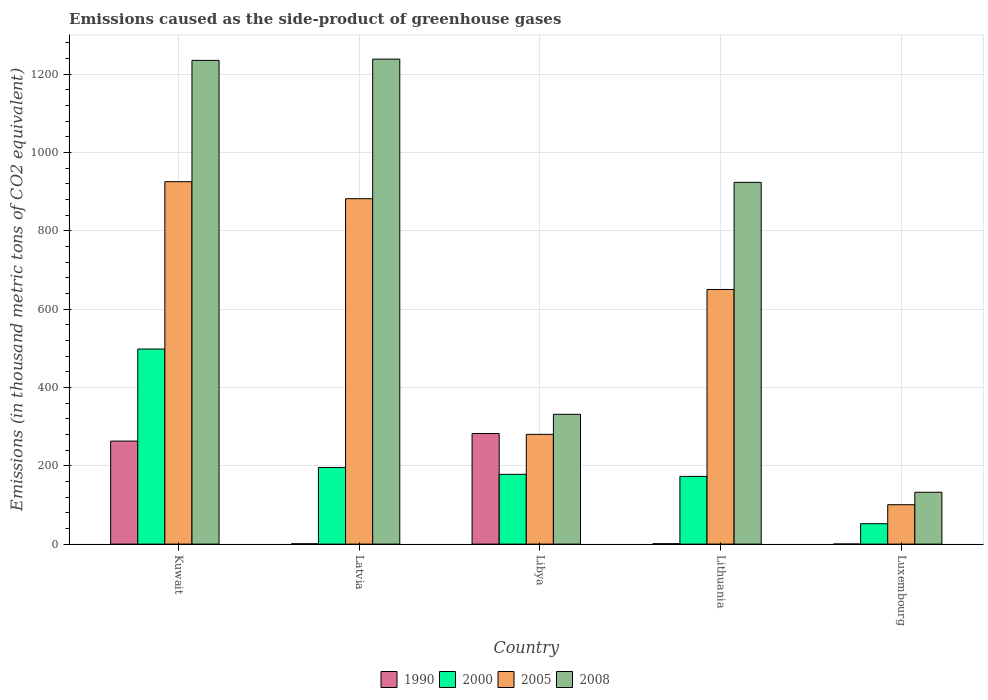How many different coloured bars are there?
Offer a very short reply. 4. How many groups of bars are there?
Your answer should be compact. 5. Are the number of bars per tick equal to the number of legend labels?
Your response must be concise. Yes. How many bars are there on the 3rd tick from the left?
Provide a succinct answer. 4. How many bars are there on the 5th tick from the right?
Your answer should be compact. 4. What is the label of the 4th group of bars from the left?
Keep it short and to the point. Lithuania. In how many cases, is the number of bars for a given country not equal to the number of legend labels?
Provide a succinct answer. 0. What is the emissions caused as the side-product of greenhouse gases in 2005 in Lithuania?
Offer a very short reply. 650.3. Across all countries, what is the maximum emissions caused as the side-product of greenhouse gases in 2005?
Your answer should be compact. 925.6. Across all countries, what is the minimum emissions caused as the side-product of greenhouse gases in 2000?
Your answer should be very brief. 52.1. In which country was the emissions caused as the side-product of greenhouse gases in 2005 maximum?
Offer a very short reply. Kuwait. In which country was the emissions caused as the side-product of greenhouse gases in 1990 minimum?
Keep it short and to the point. Luxembourg. What is the total emissions caused as the side-product of greenhouse gases in 1990 in the graph?
Your answer should be compact. 547.5. What is the difference between the emissions caused as the side-product of greenhouse gases in 2005 in Kuwait and that in Libya?
Provide a succinct answer. 645.3. What is the difference between the emissions caused as the side-product of greenhouse gases in 1990 in Kuwait and the emissions caused as the side-product of greenhouse gases in 2005 in Latvia?
Offer a very short reply. -619. What is the average emissions caused as the side-product of greenhouse gases in 1990 per country?
Keep it short and to the point. 109.5. What is the difference between the emissions caused as the side-product of greenhouse gases of/in 2000 and emissions caused as the side-product of greenhouse gases of/in 2005 in Luxembourg?
Make the answer very short. -48.5. In how many countries, is the emissions caused as the side-product of greenhouse gases in 2000 greater than 800 thousand metric tons?
Keep it short and to the point. 0. What is the ratio of the emissions caused as the side-product of greenhouse gases in 2005 in Kuwait to that in Lithuania?
Ensure brevity in your answer.  1.42. Is the difference between the emissions caused as the side-product of greenhouse gases in 2000 in Lithuania and Luxembourg greater than the difference between the emissions caused as the side-product of greenhouse gases in 2005 in Lithuania and Luxembourg?
Ensure brevity in your answer.  No. What is the difference between the highest and the second highest emissions caused as the side-product of greenhouse gases in 1990?
Offer a terse response. -281.4. What is the difference between the highest and the lowest emissions caused as the side-product of greenhouse gases in 1990?
Offer a terse response. 282.2. In how many countries, is the emissions caused as the side-product of greenhouse gases in 2008 greater than the average emissions caused as the side-product of greenhouse gases in 2008 taken over all countries?
Keep it short and to the point. 3. What does the 4th bar from the left in Kuwait represents?
Make the answer very short. 2008. Is it the case that in every country, the sum of the emissions caused as the side-product of greenhouse gases in 2005 and emissions caused as the side-product of greenhouse gases in 2000 is greater than the emissions caused as the side-product of greenhouse gases in 2008?
Make the answer very short. No. Are the values on the major ticks of Y-axis written in scientific E-notation?
Ensure brevity in your answer.  No. Does the graph contain grids?
Your response must be concise. Yes. How many legend labels are there?
Offer a terse response. 4. What is the title of the graph?
Your response must be concise. Emissions caused as the side-product of greenhouse gases. What is the label or title of the X-axis?
Keep it short and to the point. Country. What is the label or title of the Y-axis?
Provide a succinct answer. Emissions (in thousand metric tons of CO2 equivalent). What is the Emissions (in thousand metric tons of CO2 equivalent) of 1990 in Kuwait?
Your response must be concise. 263.1. What is the Emissions (in thousand metric tons of CO2 equivalent) of 2000 in Kuwait?
Give a very brief answer. 498.2. What is the Emissions (in thousand metric tons of CO2 equivalent) of 2005 in Kuwait?
Provide a succinct answer. 925.6. What is the Emissions (in thousand metric tons of CO2 equivalent) of 2008 in Kuwait?
Offer a terse response. 1235.4. What is the Emissions (in thousand metric tons of CO2 equivalent) in 2000 in Latvia?
Provide a succinct answer. 195.7. What is the Emissions (in thousand metric tons of CO2 equivalent) of 2005 in Latvia?
Your answer should be compact. 882.1. What is the Emissions (in thousand metric tons of CO2 equivalent) in 2008 in Latvia?
Your answer should be very brief. 1238.6. What is the Emissions (in thousand metric tons of CO2 equivalent) in 1990 in Libya?
Offer a very short reply. 282.4. What is the Emissions (in thousand metric tons of CO2 equivalent) in 2000 in Libya?
Your response must be concise. 178.2. What is the Emissions (in thousand metric tons of CO2 equivalent) of 2005 in Libya?
Ensure brevity in your answer.  280.3. What is the Emissions (in thousand metric tons of CO2 equivalent) of 2008 in Libya?
Your answer should be compact. 331.5. What is the Emissions (in thousand metric tons of CO2 equivalent) in 2000 in Lithuania?
Your response must be concise. 172.9. What is the Emissions (in thousand metric tons of CO2 equivalent) of 2005 in Lithuania?
Provide a short and direct response. 650.3. What is the Emissions (in thousand metric tons of CO2 equivalent) of 2008 in Lithuania?
Offer a terse response. 923.9. What is the Emissions (in thousand metric tons of CO2 equivalent) of 1990 in Luxembourg?
Provide a succinct answer. 0.2. What is the Emissions (in thousand metric tons of CO2 equivalent) in 2000 in Luxembourg?
Keep it short and to the point. 52.1. What is the Emissions (in thousand metric tons of CO2 equivalent) of 2005 in Luxembourg?
Keep it short and to the point. 100.6. What is the Emissions (in thousand metric tons of CO2 equivalent) of 2008 in Luxembourg?
Offer a very short reply. 132.4. Across all countries, what is the maximum Emissions (in thousand metric tons of CO2 equivalent) of 1990?
Provide a succinct answer. 282.4. Across all countries, what is the maximum Emissions (in thousand metric tons of CO2 equivalent) in 2000?
Provide a succinct answer. 498.2. Across all countries, what is the maximum Emissions (in thousand metric tons of CO2 equivalent) of 2005?
Provide a short and direct response. 925.6. Across all countries, what is the maximum Emissions (in thousand metric tons of CO2 equivalent) in 2008?
Offer a very short reply. 1238.6. Across all countries, what is the minimum Emissions (in thousand metric tons of CO2 equivalent) in 2000?
Ensure brevity in your answer.  52.1. Across all countries, what is the minimum Emissions (in thousand metric tons of CO2 equivalent) of 2005?
Keep it short and to the point. 100.6. Across all countries, what is the minimum Emissions (in thousand metric tons of CO2 equivalent) of 2008?
Provide a short and direct response. 132.4. What is the total Emissions (in thousand metric tons of CO2 equivalent) of 1990 in the graph?
Provide a short and direct response. 547.5. What is the total Emissions (in thousand metric tons of CO2 equivalent) of 2000 in the graph?
Ensure brevity in your answer.  1097.1. What is the total Emissions (in thousand metric tons of CO2 equivalent) of 2005 in the graph?
Provide a succinct answer. 2838.9. What is the total Emissions (in thousand metric tons of CO2 equivalent) in 2008 in the graph?
Your answer should be very brief. 3861.8. What is the difference between the Emissions (in thousand metric tons of CO2 equivalent) in 1990 in Kuwait and that in Latvia?
Provide a succinct answer. 262.3. What is the difference between the Emissions (in thousand metric tons of CO2 equivalent) in 2000 in Kuwait and that in Latvia?
Provide a short and direct response. 302.5. What is the difference between the Emissions (in thousand metric tons of CO2 equivalent) of 2005 in Kuwait and that in Latvia?
Your answer should be very brief. 43.5. What is the difference between the Emissions (in thousand metric tons of CO2 equivalent) of 1990 in Kuwait and that in Libya?
Your answer should be very brief. -19.3. What is the difference between the Emissions (in thousand metric tons of CO2 equivalent) in 2000 in Kuwait and that in Libya?
Provide a short and direct response. 320. What is the difference between the Emissions (in thousand metric tons of CO2 equivalent) of 2005 in Kuwait and that in Libya?
Provide a short and direct response. 645.3. What is the difference between the Emissions (in thousand metric tons of CO2 equivalent) in 2008 in Kuwait and that in Libya?
Your answer should be compact. 903.9. What is the difference between the Emissions (in thousand metric tons of CO2 equivalent) in 1990 in Kuwait and that in Lithuania?
Offer a very short reply. 262.1. What is the difference between the Emissions (in thousand metric tons of CO2 equivalent) of 2000 in Kuwait and that in Lithuania?
Ensure brevity in your answer.  325.3. What is the difference between the Emissions (in thousand metric tons of CO2 equivalent) in 2005 in Kuwait and that in Lithuania?
Your answer should be compact. 275.3. What is the difference between the Emissions (in thousand metric tons of CO2 equivalent) of 2008 in Kuwait and that in Lithuania?
Keep it short and to the point. 311.5. What is the difference between the Emissions (in thousand metric tons of CO2 equivalent) in 1990 in Kuwait and that in Luxembourg?
Provide a succinct answer. 262.9. What is the difference between the Emissions (in thousand metric tons of CO2 equivalent) in 2000 in Kuwait and that in Luxembourg?
Provide a succinct answer. 446.1. What is the difference between the Emissions (in thousand metric tons of CO2 equivalent) of 2005 in Kuwait and that in Luxembourg?
Your response must be concise. 825. What is the difference between the Emissions (in thousand metric tons of CO2 equivalent) in 2008 in Kuwait and that in Luxembourg?
Ensure brevity in your answer.  1103. What is the difference between the Emissions (in thousand metric tons of CO2 equivalent) of 1990 in Latvia and that in Libya?
Provide a succinct answer. -281.6. What is the difference between the Emissions (in thousand metric tons of CO2 equivalent) of 2005 in Latvia and that in Libya?
Your answer should be compact. 601.8. What is the difference between the Emissions (in thousand metric tons of CO2 equivalent) in 2008 in Latvia and that in Libya?
Keep it short and to the point. 907.1. What is the difference between the Emissions (in thousand metric tons of CO2 equivalent) in 2000 in Latvia and that in Lithuania?
Your answer should be compact. 22.8. What is the difference between the Emissions (in thousand metric tons of CO2 equivalent) in 2005 in Latvia and that in Lithuania?
Offer a terse response. 231.8. What is the difference between the Emissions (in thousand metric tons of CO2 equivalent) of 2008 in Latvia and that in Lithuania?
Your answer should be very brief. 314.7. What is the difference between the Emissions (in thousand metric tons of CO2 equivalent) of 2000 in Latvia and that in Luxembourg?
Ensure brevity in your answer.  143.6. What is the difference between the Emissions (in thousand metric tons of CO2 equivalent) of 2005 in Latvia and that in Luxembourg?
Your answer should be compact. 781.5. What is the difference between the Emissions (in thousand metric tons of CO2 equivalent) in 2008 in Latvia and that in Luxembourg?
Provide a succinct answer. 1106.2. What is the difference between the Emissions (in thousand metric tons of CO2 equivalent) in 1990 in Libya and that in Lithuania?
Your answer should be very brief. 281.4. What is the difference between the Emissions (in thousand metric tons of CO2 equivalent) of 2000 in Libya and that in Lithuania?
Offer a very short reply. 5.3. What is the difference between the Emissions (in thousand metric tons of CO2 equivalent) in 2005 in Libya and that in Lithuania?
Make the answer very short. -370. What is the difference between the Emissions (in thousand metric tons of CO2 equivalent) in 2008 in Libya and that in Lithuania?
Make the answer very short. -592.4. What is the difference between the Emissions (in thousand metric tons of CO2 equivalent) of 1990 in Libya and that in Luxembourg?
Offer a terse response. 282.2. What is the difference between the Emissions (in thousand metric tons of CO2 equivalent) of 2000 in Libya and that in Luxembourg?
Provide a short and direct response. 126.1. What is the difference between the Emissions (in thousand metric tons of CO2 equivalent) of 2005 in Libya and that in Luxembourg?
Your response must be concise. 179.7. What is the difference between the Emissions (in thousand metric tons of CO2 equivalent) of 2008 in Libya and that in Luxembourg?
Your answer should be very brief. 199.1. What is the difference between the Emissions (in thousand metric tons of CO2 equivalent) in 1990 in Lithuania and that in Luxembourg?
Provide a short and direct response. 0.8. What is the difference between the Emissions (in thousand metric tons of CO2 equivalent) in 2000 in Lithuania and that in Luxembourg?
Your answer should be compact. 120.8. What is the difference between the Emissions (in thousand metric tons of CO2 equivalent) of 2005 in Lithuania and that in Luxembourg?
Offer a terse response. 549.7. What is the difference between the Emissions (in thousand metric tons of CO2 equivalent) of 2008 in Lithuania and that in Luxembourg?
Provide a succinct answer. 791.5. What is the difference between the Emissions (in thousand metric tons of CO2 equivalent) in 1990 in Kuwait and the Emissions (in thousand metric tons of CO2 equivalent) in 2000 in Latvia?
Your response must be concise. 67.4. What is the difference between the Emissions (in thousand metric tons of CO2 equivalent) in 1990 in Kuwait and the Emissions (in thousand metric tons of CO2 equivalent) in 2005 in Latvia?
Your response must be concise. -619. What is the difference between the Emissions (in thousand metric tons of CO2 equivalent) of 1990 in Kuwait and the Emissions (in thousand metric tons of CO2 equivalent) of 2008 in Latvia?
Make the answer very short. -975.5. What is the difference between the Emissions (in thousand metric tons of CO2 equivalent) of 2000 in Kuwait and the Emissions (in thousand metric tons of CO2 equivalent) of 2005 in Latvia?
Give a very brief answer. -383.9. What is the difference between the Emissions (in thousand metric tons of CO2 equivalent) of 2000 in Kuwait and the Emissions (in thousand metric tons of CO2 equivalent) of 2008 in Latvia?
Provide a succinct answer. -740.4. What is the difference between the Emissions (in thousand metric tons of CO2 equivalent) in 2005 in Kuwait and the Emissions (in thousand metric tons of CO2 equivalent) in 2008 in Latvia?
Offer a terse response. -313. What is the difference between the Emissions (in thousand metric tons of CO2 equivalent) of 1990 in Kuwait and the Emissions (in thousand metric tons of CO2 equivalent) of 2000 in Libya?
Make the answer very short. 84.9. What is the difference between the Emissions (in thousand metric tons of CO2 equivalent) of 1990 in Kuwait and the Emissions (in thousand metric tons of CO2 equivalent) of 2005 in Libya?
Make the answer very short. -17.2. What is the difference between the Emissions (in thousand metric tons of CO2 equivalent) in 1990 in Kuwait and the Emissions (in thousand metric tons of CO2 equivalent) in 2008 in Libya?
Provide a succinct answer. -68.4. What is the difference between the Emissions (in thousand metric tons of CO2 equivalent) in 2000 in Kuwait and the Emissions (in thousand metric tons of CO2 equivalent) in 2005 in Libya?
Offer a very short reply. 217.9. What is the difference between the Emissions (in thousand metric tons of CO2 equivalent) in 2000 in Kuwait and the Emissions (in thousand metric tons of CO2 equivalent) in 2008 in Libya?
Make the answer very short. 166.7. What is the difference between the Emissions (in thousand metric tons of CO2 equivalent) of 2005 in Kuwait and the Emissions (in thousand metric tons of CO2 equivalent) of 2008 in Libya?
Make the answer very short. 594.1. What is the difference between the Emissions (in thousand metric tons of CO2 equivalent) of 1990 in Kuwait and the Emissions (in thousand metric tons of CO2 equivalent) of 2000 in Lithuania?
Make the answer very short. 90.2. What is the difference between the Emissions (in thousand metric tons of CO2 equivalent) in 1990 in Kuwait and the Emissions (in thousand metric tons of CO2 equivalent) in 2005 in Lithuania?
Give a very brief answer. -387.2. What is the difference between the Emissions (in thousand metric tons of CO2 equivalent) in 1990 in Kuwait and the Emissions (in thousand metric tons of CO2 equivalent) in 2008 in Lithuania?
Offer a very short reply. -660.8. What is the difference between the Emissions (in thousand metric tons of CO2 equivalent) in 2000 in Kuwait and the Emissions (in thousand metric tons of CO2 equivalent) in 2005 in Lithuania?
Make the answer very short. -152.1. What is the difference between the Emissions (in thousand metric tons of CO2 equivalent) in 2000 in Kuwait and the Emissions (in thousand metric tons of CO2 equivalent) in 2008 in Lithuania?
Make the answer very short. -425.7. What is the difference between the Emissions (in thousand metric tons of CO2 equivalent) of 1990 in Kuwait and the Emissions (in thousand metric tons of CO2 equivalent) of 2000 in Luxembourg?
Your answer should be very brief. 211. What is the difference between the Emissions (in thousand metric tons of CO2 equivalent) in 1990 in Kuwait and the Emissions (in thousand metric tons of CO2 equivalent) in 2005 in Luxembourg?
Offer a very short reply. 162.5. What is the difference between the Emissions (in thousand metric tons of CO2 equivalent) of 1990 in Kuwait and the Emissions (in thousand metric tons of CO2 equivalent) of 2008 in Luxembourg?
Your answer should be compact. 130.7. What is the difference between the Emissions (in thousand metric tons of CO2 equivalent) of 2000 in Kuwait and the Emissions (in thousand metric tons of CO2 equivalent) of 2005 in Luxembourg?
Your answer should be compact. 397.6. What is the difference between the Emissions (in thousand metric tons of CO2 equivalent) in 2000 in Kuwait and the Emissions (in thousand metric tons of CO2 equivalent) in 2008 in Luxembourg?
Your answer should be very brief. 365.8. What is the difference between the Emissions (in thousand metric tons of CO2 equivalent) of 2005 in Kuwait and the Emissions (in thousand metric tons of CO2 equivalent) of 2008 in Luxembourg?
Give a very brief answer. 793.2. What is the difference between the Emissions (in thousand metric tons of CO2 equivalent) of 1990 in Latvia and the Emissions (in thousand metric tons of CO2 equivalent) of 2000 in Libya?
Offer a terse response. -177.4. What is the difference between the Emissions (in thousand metric tons of CO2 equivalent) of 1990 in Latvia and the Emissions (in thousand metric tons of CO2 equivalent) of 2005 in Libya?
Your answer should be compact. -279.5. What is the difference between the Emissions (in thousand metric tons of CO2 equivalent) in 1990 in Latvia and the Emissions (in thousand metric tons of CO2 equivalent) in 2008 in Libya?
Your response must be concise. -330.7. What is the difference between the Emissions (in thousand metric tons of CO2 equivalent) of 2000 in Latvia and the Emissions (in thousand metric tons of CO2 equivalent) of 2005 in Libya?
Keep it short and to the point. -84.6. What is the difference between the Emissions (in thousand metric tons of CO2 equivalent) of 2000 in Latvia and the Emissions (in thousand metric tons of CO2 equivalent) of 2008 in Libya?
Give a very brief answer. -135.8. What is the difference between the Emissions (in thousand metric tons of CO2 equivalent) in 2005 in Latvia and the Emissions (in thousand metric tons of CO2 equivalent) in 2008 in Libya?
Your answer should be very brief. 550.6. What is the difference between the Emissions (in thousand metric tons of CO2 equivalent) of 1990 in Latvia and the Emissions (in thousand metric tons of CO2 equivalent) of 2000 in Lithuania?
Give a very brief answer. -172.1. What is the difference between the Emissions (in thousand metric tons of CO2 equivalent) in 1990 in Latvia and the Emissions (in thousand metric tons of CO2 equivalent) in 2005 in Lithuania?
Provide a short and direct response. -649.5. What is the difference between the Emissions (in thousand metric tons of CO2 equivalent) in 1990 in Latvia and the Emissions (in thousand metric tons of CO2 equivalent) in 2008 in Lithuania?
Your response must be concise. -923.1. What is the difference between the Emissions (in thousand metric tons of CO2 equivalent) in 2000 in Latvia and the Emissions (in thousand metric tons of CO2 equivalent) in 2005 in Lithuania?
Provide a succinct answer. -454.6. What is the difference between the Emissions (in thousand metric tons of CO2 equivalent) of 2000 in Latvia and the Emissions (in thousand metric tons of CO2 equivalent) of 2008 in Lithuania?
Offer a very short reply. -728.2. What is the difference between the Emissions (in thousand metric tons of CO2 equivalent) in 2005 in Latvia and the Emissions (in thousand metric tons of CO2 equivalent) in 2008 in Lithuania?
Give a very brief answer. -41.8. What is the difference between the Emissions (in thousand metric tons of CO2 equivalent) of 1990 in Latvia and the Emissions (in thousand metric tons of CO2 equivalent) of 2000 in Luxembourg?
Your answer should be compact. -51.3. What is the difference between the Emissions (in thousand metric tons of CO2 equivalent) of 1990 in Latvia and the Emissions (in thousand metric tons of CO2 equivalent) of 2005 in Luxembourg?
Ensure brevity in your answer.  -99.8. What is the difference between the Emissions (in thousand metric tons of CO2 equivalent) in 1990 in Latvia and the Emissions (in thousand metric tons of CO2 equivalent) in 2008 in Luxembourg?
Give a very brief answer. -131.6. What is the difference between the Emissions (in thousand metric tons of CO2 equivalent) of 2000 in Latvia and the Emissions (in thousand metric tons of CO2 equivalent) of 2005 in Luxembourg?
Provide a short and direct response. 95.1. What is the difference between the Emissions (in thousand metric tons of CO2 equivalent) of 2000 in Latvia and the Emissions (in thousand metric tons of CO2 equivalent) of 2008 in Luxembourg?
Your answer should be very brief. 63.3. What is the difference between the Emissions (in thousand metric tons of CO2 equivalent) in 2005 in Latvia and the Emissions (in thousand metric tons of CO2 equivalent) in 2008 in Luxembourg?
Provide a succinct answer. 749.7. What is the difference between the Emissions (in thousand metric tons of CO2 equivalent) of 1990 in Libya and the Emissions (in thousand metric tons of CO2 equivalent) of 2000 in Lithuania?
Give a very brief answer. 109.5. What is the difference between the Emissions (in thousand metric tons of CO2 equivalent) of 1990 in Libya and the Emissions (in thousand metric tons of CO2 equivalent) of 2005 in Lithuania?
Give a very brief answer. -367.9. What is the difference between the Emissions (in thousand metric tons of CO2 equivalent) of 1990 in Libya and the Emissions (in thousand metric tons of CO2 equivalent) of 2008 in Lithuania?
Give a very brief answer. -641.5. What is the difference between the Emissions (in thousand metric tons of CO2 equivalent) of 2000 in Libya and the Emissions (in thousand metric tons of CO2 equivalent) of 2005 in Lithuania?
Provide a succinct answer. -472.1. What is the difference between the Emissions (in thousand metric tons of CO2 equivalent) of 2000 in Libya and the Emissions (in thousand metric tons of CO2 equivalent) of 2008 in Lithuania?
Ensure brevity in your answer.  -745.7. What is the difference between the Emissions (in thousand metric tons of CO2 equivalent) of 2005 in Libya and the Emissions (in thousand metric tons of CO2 equivalent) of 2008 in Lithuania?
Offer a very short reply. -643.6. What is the difference between the Emissions (in thousand metric tons of CO2 equivalent) of 1990 in Libya and the Emissions (in thousand metric tons of CO2 equivalent) of 2000 in Luxembourg?
Offer a terse response. 230.3. What is the difference between the Emissions (in thousand metric tons of CO2 equivalent) of 1990 in Libya and the Emissions (in thousand metric tons of CO2 equivalent) of 2005 in Luxembourg?
Keep it short and to the point. 181.8. What is the difference between the Emissions (in thousand metric tons of CO2 equivalent) in 1990 in Libya and the Emissions (in thousand metric tons of CO2 equivalent) in 2008 in Luxembourg?
Ensure brevity in your answer.  150. What is the difference between the Emissions (in thousand metric tons of CO2 equivalent) of 2000 in Libya and the Emissions (in thousand metric tons of CO2 equivalent) of 2005 in Luxembourg?
Your response must be concise. 77.6. What is the difference between the Emissions (in thousand metric tons of CO2 equivalent) of 2000 in Libya and the Emissions (in thousand metric tons of CO2 equivalent) of 2008 in Luxembourg?
Offer a very short reply. 45.8. What is the difference between the Emissions (in thousand metric tons of CO2 equivalent) in 2005 in Libya and the Emissions (in thousand metric tons of CO2 equivalent) in 2008 in Luxembourg?
Keep it short and to the point. 147.9. What is the difference between the Emissions (in thousand metric tons of CO2 equivalent) in 1990 in Lithuania and the Emissions (in thousand metric tons of CO2 equivalent) in 2000 in Luxembourg?
Ensure brevity in your answer.  -51.1. What is the difference between the Emissions (in thousand metric tons of CO2 equivalent) in 1990 in Lithuania and the Emissions (in thousand metric tons of CO2 equivalent) in 2005 in Luxembourg?
Offer a terse response. -99.6. What is the difference between the Emissions (in thousand metric tons of CO2 equivalent) in 1990 in Lithuania and the Emissions (in thousand metric tons of CO2 equivalent) in 2008 in Luxembourg?
Your answer should be very brief. -131.4. What is the difference between the Emissions (in thousand metric tons of CO2 equivalent) in 2000 in Lithuania and the Emissions (in thousand metric tons of CO2 equivalent) in 2005 in Luxembourg?
Make the answer very short. 72.3. What is the difference between the Emissions (in thousand metric tons of CO2 equivalent) in 2000 in Lithuania and the Emissions (in thousand metric tons of CO2 equivalent) in 2008 in Luxembourg?
Provide a succinct answer. 40.5. What is the difference between the Emissions (in thousand metric tons of CO2 equivalent) in 2005 in Lithuania and the Emissions (in thousand metric tons of CO2 equivalent) in 2008 in Luxembourg?
Your answer should be very brief. 517.9. What is the average Emissions (in thousand metric tons of CO2 equivalent) in 1990 per country?
Offer a terse response. 109.5. What is the average Emissions (in thousand metric tons of CO2 equivalent) of 2000 per country?
Keep it short and to the point. 219.42. What is the average Emissions (in thousand metric tons of CO2 equivalent) in 2005 per country?
Offer a very short reply. 567.78. What is the average Emissions (in thousand metric tons of CO2 equivalent) of 2008 per country?
Make the answer very short. 772.36. What is the difference between the Emissions (in thousand metric tons of CO2 equivalent) of 1990 and Emissions (in thousand metric tons of CO2 equivalent) of 2000 in Kuwait?
Offer a very short reply. -235.1. What is the difference between the Emissions (in thousand metric tons of CO2 equivalent) in 1990 and Emissions (in thousand metric tons of CO2 equivalent) in 2005 in Kuwait?
Offer a very short reply. -662.5. What is the difference between the Emissions (in thousand metric tons of CO2 equivalent) of 1990 and Emissions (in thousand metric tons of CO2 equivalent) of 2008 in Kuwait?
Provide a succinct answer. -972.3. What is the difference between the Emissions (in thousand metric tons of CO2 equivalent) in 2000 and Emissions (in thousand metric tons of CO2 equivalent) in 2005 in Kuwait?
Offer a terse response. -427.4. What is the difference between the Emissions (in thousand metric tons of CO2 equivalent) of 2000 and Emissions (in thousand metric tons of CO2 equivalent) of 2008 in Kuwait?
Make the answer very short. -737.2. What is the difference between the Emissions (in thousand metric tons of CO2 equivalent) in 2005 and Emissions (in thousand metric tons of CO2 equivalent) in 2008 in Kuwait?
Keep it short and to the point. -309.8. What is the difference between the Emissions (in thousand metric tons of CO2 equivalent) of 1990 and Emissions (in thousand metric tons of CO2 equivalent) of 2000 in Latvia?
Your answer should be very brief. -194.9. What is the difference between the Emissions (in thousand metric tons of CO2 equivalent) of 1990 and Emissions (in thousand metric tons of CO2 equivalent) of 2005 in Latvia?
Provide a succinct answer. -881.3. What is the difference between the Emissions (in thousand metric tons of CO2 equivalent) in 1990 and Emissions (in thousand metric tons of CO2 equivalent) in 2008 in Latvia?
Make the answer very short. -1237.8. What is the difference between the Emissions (in thousand metric tons of CO2 equivalent) of 2000 and Emissions (in thousand metric tons of CO2 equivalent) of 2005 in Latvia?
Your answer should be very brief. -686.4. What is the difference between the Emissions (in thousand metric tons of CO2 equivalent) in 2000 and Emissions (in thousand metric tons of CO2 equivalent) in 2008 in Latvia?
Your response must be concise. -1042.9. What is the difference between the Emissions (in thousand metric tons of CO2 equivalent) in 2005 and Emissions (in thousand metric tons of CO2 equivalent) in 2008 in Latvia?
Offer a terse response. -356.5. What is the difference between the Emissions (in thousand metric tons of CO2 equivalent) of 1990 and Emissions (in thousand metric tons of CO2 equivalent) of 2000 in Libya?
Offer a very short reply. 104.2. What is the difference between the Emissions (in thousand metric tons of CO2 equivalent) of 1990 and Emissions (in thousand metric tons of CO2 equivalent) of 2005 in Libya?
Offer a terse response. 2.1. What is the difference between the Emissions (in thousand metric tons of CO2 equivalent) of 1990 and Emissions (in thousand metric tons of CO2 equivalent) of 2008 in Libya?
Give a very brief answer. -49.1. What is the difference between the Emissions (in thousand metric tons of CO2 equivalent) in 2000 and Emissions (in thousand metric tons of CO2 equivalent) in 2005 in Libya?
Offer a terse response. -102.1. What is the difference between the Emissions (in thousand metric tons of CO2 equivalent) in 2000 and Emissions (in thousand metric tons of CO2 equivalent) in 2008 in Libya?
Offer a very short reply. -153.3. What is the difference between the Emissions (in thousand metric tons of CO2 equivalent) of 2005 and Emissions (in thousand metric tons of CO2 equivalent) of 2008 in Libya?
Make the answer very short. -51.2. What is the difference between the Emissions (in thousand metric tons of CO2 equivalent) in 1990 and Emissions (in thousand metric tons of CO2 equivalent) in 2000 in Lithuania?
Ensure brevity in your answer.  -171.9. What is the difference between the Emissions (in thousand metric tons of CO2 equivalent) of 1990 and Emissions (in thousand metric tons of CO2 equivalent) of 2005 in Lithuania?
Your response must be concise. -649.3. What is the difference between the Emissions (in thousand metric tons of CO2 equivalent) of 1990 and Emissions (in thousand metric tons of CO2 equivalent) of 2008 in Lithuania?
Offer a very short reply. -922.9. What is the difference between the Emissions (in thousand metric tons of CO2 equivalent) in 2000 and Emissions (in thousand metric tons of CO2 equivalent) in 2005 in Lithuania?
Keep it short and to the point. -477.4. What is the difference between the Emissions (in thousand metric tons of CO2 equivalent) in 2000 and Emissions (in thousand metric tons of CO2 equivalent) in 2008 in Lithuania?
Your answer should be very brief. -751. What is the difference between the Emissions (in thousand metric tons of CO2 equivalent) in 2005 and Emissions (in thousand metric tons of CO2 equivalent) in 2008 in Lithuania?
Provide a short and direct response. -273.6. What is the difference between the Emissions (in thousand metric tons of CO2 equivalent) in 1990 and Emissions (in thousand metric tons of CO2 equivalent) in 2000 in Luxembourg?
Keep it short and to the point. -51.9. What is the difference between the Emissions (in thousand metric tons of CO2 equivalent) of 1990 and Emissions (in thousand metric tons of CO2 equivalent) of 2005 in Luxembourg?
Make the answer very short. -100.4. What is the difference between the Emissions (in thousand metric tons of CO2 equivalent) of 1990 and Emissions (in thousand metric tons of CO2 equivalent) of 2008 in Luxembourg?
Give a very brief answer. -132.2. What is the difference between the Emissions (in thousand metric tons of CO2 equivalent) in 2000 and Emissions (in thousand metric tons of CO2 equivalent) in 2005 in Luxembourg?
Offer a terse response. -48.5. What is the difference between the Emissions (in thousand metric tons of CO2 equivalent) in 2000 and Emissions (in thousand metric tons of CO2 equivalent) in 2008 in Luxembourg?
Provide a short and direct response. -80.3. What is the difference between the Emissions (in thousand metric tons of CO2 equivalent) in 2005 and Emissions (in thousand metric tons of CO2 equivalent) in 2008 in Luxembourg?
Offer a terse response. -31.8. What is the ratio of the Emissions (in thousand metric tons of CO2 equivalent) of 1990 in Kuwait to that in Latvia?
Your answer should be very brief. 328.88. What is the ratio of the Emissions (in thousand metric tons of CO2 equivalent) in 2000 in Kuwait to that in Latvia?
Provide a short and direct response. 2.55. What is the ratio of the Emissions (in thousand metric tons of CO2 equivalent) of 2005 in Kuwait to that in Latvia?
Provide a short and direct response. 1.05. What is the ratio of the Emissions (in thousand metric tons of CO2 equivalent) in 2008 in Kuwait to that in Latvia?
Give a very brief answer. 1. What is the ratio of the Emissions (in thousand metric tons of CO2 equivalent) in 1990 in Kuwait to that in Libya?
Keep it short and to the point. 0.93. What is the ratio of the Emissions (in thousand metric tons of CO2 equivalent) in 2000 in Kuwait to that in Libya?
Make the answer very short. 2.8. What is the ratio of the Emissions (in thousand metric tons of CO2 equivalent) of 2005 in Kuwait to that in Libya?
Your answer should be compact. 3.3. What is the ratio of the Emissions (in thousand metric tons of CO2 equivalent) of 2008 in Kuwait to that in Libya?
Provide a succinct answer. 3.73. What is the ratio of the Emissions (in thousand metric tons of CO2 equivalent) of 1990 in Kuwait to that in Lithuania?
Keep it short and to the point. 263.1. What is the ratio of the Emissions (in thousand metric tons of CO2 equivalent) of 2000 in Kuwait to that in Lithuania?
Give a very brief answer. 2.88. What is the ratio of the Emissions (in thousand metric tons of CO2 equivalent) of 2005 in Kuwait to that in Lithuania?
Your answer should be very brief. 1.42. What is the ratio of the Emissions (in thousand metric tons of CO2 equivalent) of 2008 in Kuwait to that in Lithuania?
Give a very brief answer. 1.34. What is the ratio of the Emissions (in thousand metric tons of CO2 equivalent) of 1990 in Kuwait to that in Luxembourg?
Provide a succinct answer. 1315.5. What is the ratio of the Emissions (in thousand metric tons of CO2 equivalent) of 2000 in Kuwait to that in Luxembourg?
Your response must be concise. 9.56. What is the ratio of the Emissions (in thousand metric tons of CO2 equivalent) in 2005 in Kuwait to that in Luxembourg?
Your answer should be very brief. 9.2. What is the ratio of the Emissions (in thousand metric tons of CO2 equivalent) of 2008 in Kuwait to that in Luxembourg?
Offer a very short reply. 9.33. What is the ratio of the Emissions (in thousand metric tons of CO2 equivalent) in 1990 in Latvia to that in Libya?
Your answer should be compact. 0. What is the ratio of the Emissions (in thousand metric tons of CO2 equivalent) in 2000 in Latvia to that in Libya?
Offer a terse response. 1.1. What is the ratio of the Emissions (in thousand metric tons of CO2 equivalent) in 2005 in Latvia to that in Libya?
Your answer should be very brief. 3.15. What is the ratio of the Emissions (in thousand metric tons of CO2 equivalent) of 2008 in Latvia to that in Libya?
Keep it short and to the point. 3.74. What is the ratio of the Emissions (in thousand metric tons of CO2 equivalent) of 2000 in Latvia to that in Lithuania?
Offer a terse response. 1.13. What is the ratio of the Emissions (in thousand metric tons of CO2 equivalent) in 2005 in Latvia to that in Lithuania?
Your response must be concise. 1.36. What is the ratio of the Emissions (in thousand metric tons of CO2 equivalent) in 2008 in Latvia to that in Lithuania?
Your answer should be compact. 1.34. What is the ratio of the Emissions (in thousand metric tons of CO2 equivalent) in 2000 in Latvia to that in Luxembourg?
Provide a succinct answer. 3.76. What is the ratio of the Emissions (in thousand metric tons of CO2 equivalent) of 2005 in Latvia to that in Luxembourg?
Give a very brief answer. 8.77. What is the ratio of the Emissions (in thousand metric tons of CO2 equivalent) in 2008 in Latvia to that in Luxembourg?
Your response must be concise. 9.36. What is the ratio of the Emissions (in thousand metric tons of CO2 equivalent) in 1990 in Libya to that in Lithuania?
Keep it short and to the point. 282.4. What is the ratio of the Emissions (in thousand metric tons of CO2 equivalent) in 2000 in Libya to that in Lithuania?
Your answer should be very brief. 1.03. What is the ratio of the Emissions (in thousand metric tons of CO2 equivalent) in 2005 in Libya to that in Lithuania?
Ensure brevity in your answer.  0.43. What is the ratio of the Emissions (in thousand metric tons of CO2 equivalent) of 2008 in Libya to that in Lithuania?
Keep it short and to the point. 0.36. What is the ratio of the Emissions (in thousand metric tons of CO2 equivalent) in 1990 in Libya to that in Luxembourg?
Keep it short and to the point. 1412. What is the ratio of the Emissions (in thousand metric tons of CO2 equivalent) in 2000 in Libya to that in Luxembourg?
Make the answer very short. 3.42. What is the ratio of the Emissions (in thousand metric tons of CO2 equivalent) in 2005 in Libya to that in Luxembourg?
Your answer should be very brief. 2.79. What is the ratio of the Emissions (in thousand metric tons of CO2 equivalent) in 2008 in Libya to that in Luxembourg?
Your response must be concise. 2.5. What is the ratio of the Emissions (in thousand metric tons of CO2 equivalent) in 2000 in Lithuania to that in Luxembourg?
Your answer should be compact. 3.32. What is the ratio of the Emissions (in thousand metric tons of CO2 equivalent) of 2005 in Lithuania to that in Luxembourg?
Provide a succinct answer. 6.46. What is the ratio of the Emissions (in thousand metric tons of CO2 equivalent) of 2008 in Lithuania to that in Luxembourg?
Your response must be concise. 6.98. What is the difference between the highest and the second highest Emissions (in thousand metric tons of CO2 equivalent) of 1990?
Your answer should be compact. 19.3. What is the difference between the highest and the second highest Emissions (in thousand metric tons of CO2 equivalent) of 2000?
Ensure brevity in your answer.  302.5. What is the difference between the highest and the second highest Emissions (in thousand metric tons of CO2 equivalent) of 2005?
Offer a very short reply. 43.5. What is the difference between the highest and the lowest Emissions (in thousand metric tons of CO2 equivalent) of 1990?
Provide a succinct answer. 282.2. What is the difference between the highest and the lowest Emissions (in thousand metric tons of CO2 equivalent) in 2000?
Your answer should be very brief. 446.1. What is the difference between the highest and the lowest Emissions (in thousand metric tons of CO2 equivalent) in 2005?
Make the answer very short. 825. What is the difference between the highest and the lowest Emissions (in thousand metric tons of CO2 equivalent) of 2008?
Ensure brevity in your answer.  1106.2. 